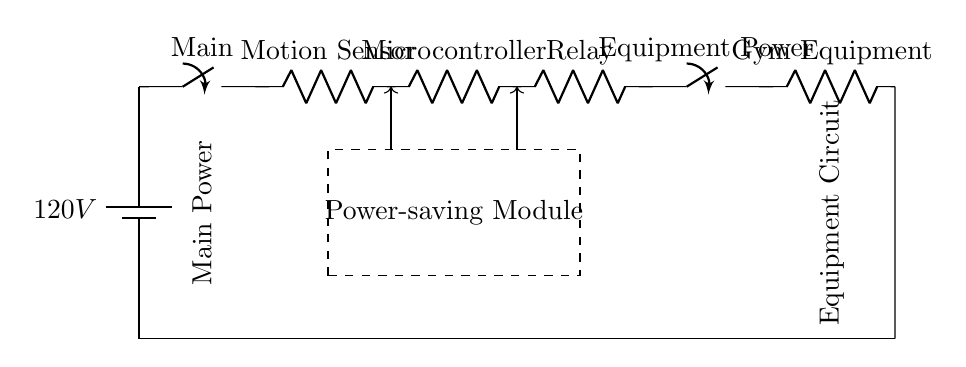What is the voltage of the circuit? The circuit has a battery connected that outputs 120 volts, which is the main voltage supply for the entire system.
Answer: 120 volts What component is used to save power? The circuit has a module labeled "Power-saving Module," which is specifically designated to reduce power consumption when the gym equipment is not in use.
Answer: Power-saving Module How many switches are there in the circuit? There are two switches in the circuit: one is labeled as "Main" and the other as "Equipment Power," both controlling different parts of the circuit.
Answer: 2 What does the relay do in this circuit? In the context of this circuit, the relay acts as a switch that is activated by the microcontroller to control the power supplied to the gym equipment, based on input from the motion sensor.
Answer: Functions as a switch What is the purpose of the motion sensor? The motion sensor detects movement, which works in conjunction with the microcontroller to establish whether the gym equipment should be powered on or off, thus saving energy.
Answer: Detects movement What is connected to the microcontroller in the circuit? The microcontroller is connected to both the motion sensor and the relay, allowing it to process inputs from the sensor and control the relay accordingly.
Answer: Motion sensor and relay 